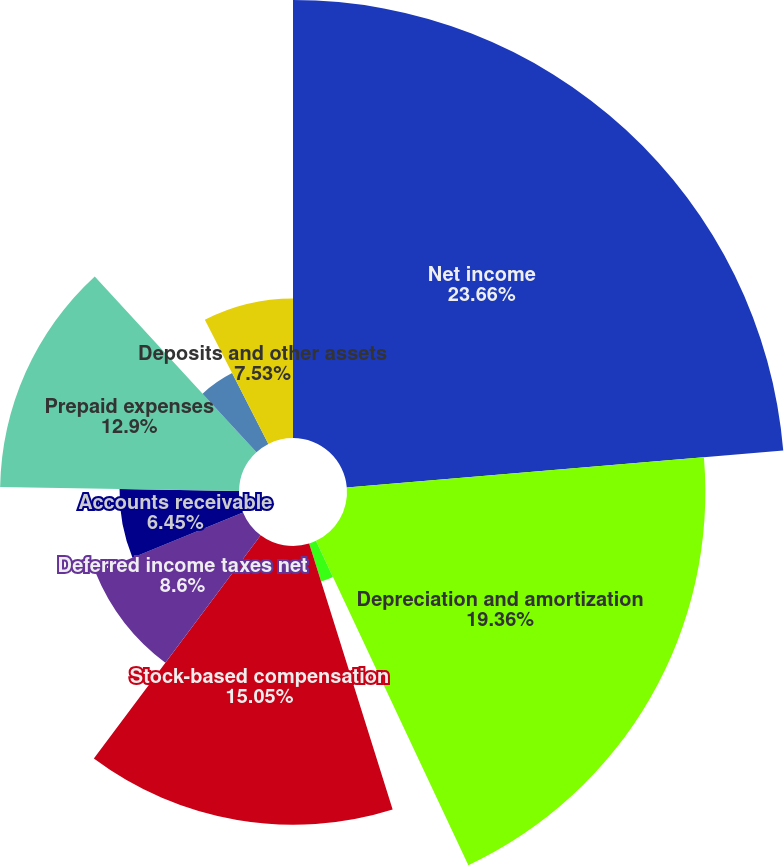Convert chart. <chart><loc_0><loc_0><loc_500><loc_500><pie_chart><fcel>Net income<fcel>Depreciation and amortization<fcel>(Gain)/loss on disposition of<fcel>Amortization of debt discount<fcel>Stock-based compensation<fcel>Deferred income taxes net<fcel>Accounts receivable<fcel>Prepaid expenses<fcel>Inventory<fcel>Deposits and other assets<nl><fcel>23.65%<fcel>19.35%<fcel>0.0%<fcel>2.15%<fcel>15.05%<fcel>8.6%<fcel>6.45%<fcel>12.9%<fcel>4.3%<fcel>7.53%<nl></chart> 